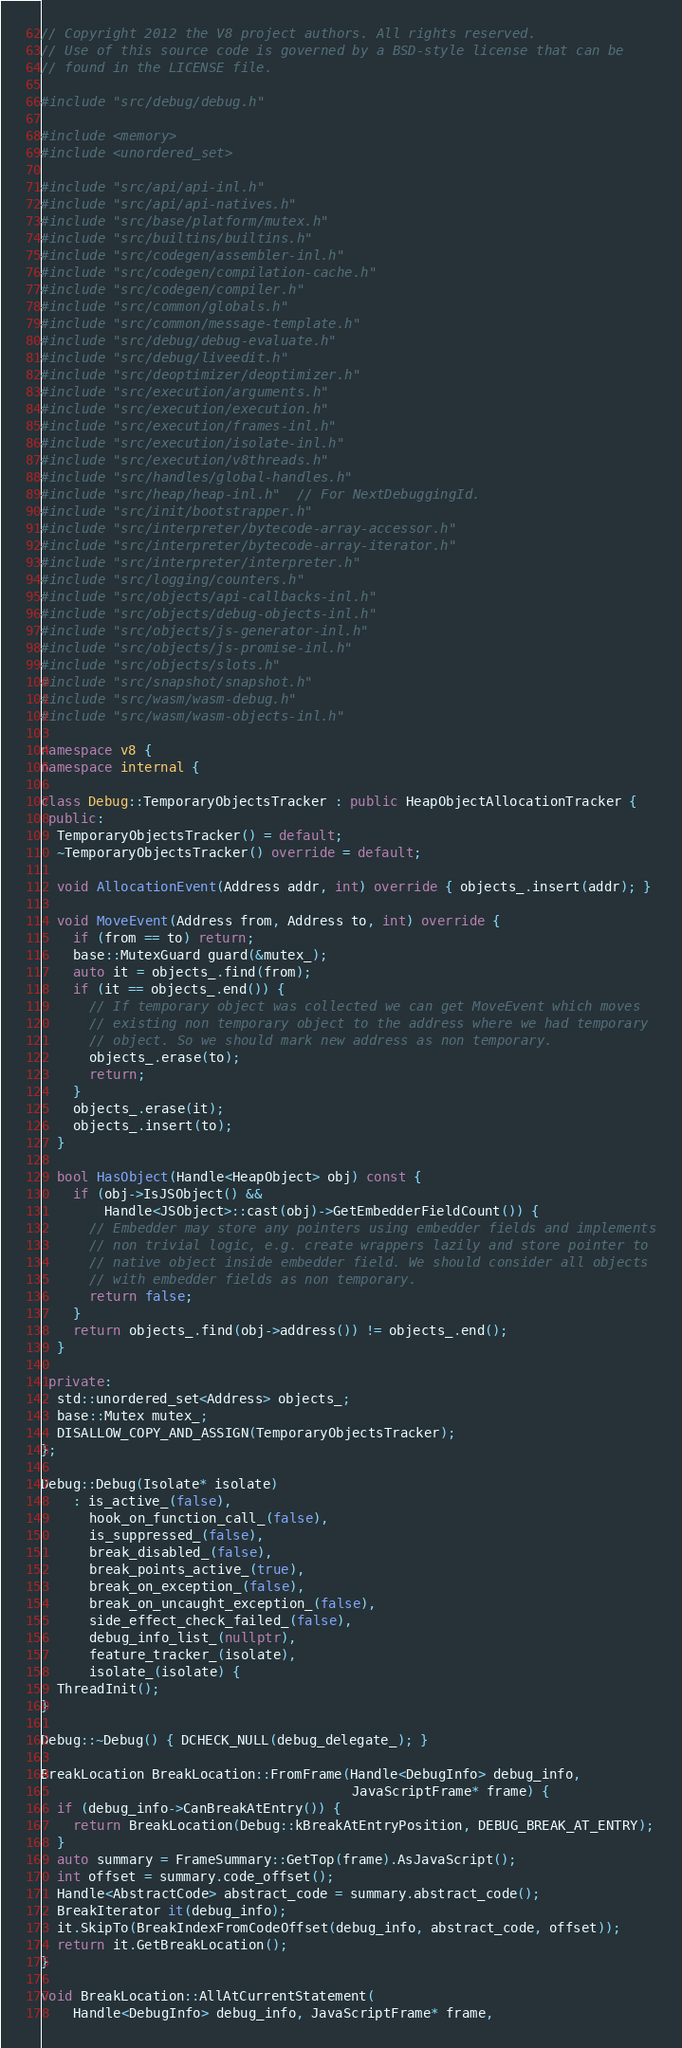Convert code to text. <code><loc_0><loc_0><loc_500><loc_500><_C++_>// Copyright 2012 the V8 project authors. All rights reserved.
// Use of this source code is governed by a BSD-style license that can be
// found in the LICENSE file.

#include "src/debug/debug.h"

#include <memory>
#include <unordered_set>

#include "src/api/api-inl.h"
#include "src/api/api-natives.h"
#include "src/base/platform/mutex.h"
#include "src/builtins/builtins.h"
#include "src/codegen/assembler-inl.h"
#include "src/codegen/compilation-cache.h"
#include "src/codegen/compiler.h"
#include "src/common/globals.h"
#include "src/common/message-template.h"
#include "src/debug/debug-evaluate.h"
#include "src/debug/liveedit.h"
#include "src/deoptimizer/deoptimizer.h"
#include "src/execution/arguments.h"
#include "src/execution/execution.h"
#include "src/execution/frames-inl.h"
#include "src/execution/isolate-inl.h"
#include "src/execution/v8threads.h"
#include "src/handles/global-handles.h"
#include "src/heap/heap-inl.h"  // For NextDebuggingId.
#include "src/init/bootstrapper.h"
#include "src/interpreter/bytecode-array-accessor.h"
#include "src/interpreter/bytecode-array-iterator.h"
#include "src/interpreter/interpreter.h"
#include "src/logging/counters.h"
#include "src/objects/api-callbacks-inl.h"
#include "src/objects/debug-objects-inl.h"
#include "src/objects/js-generator-inl.h"
#include "src/objects/js-promise-inl.h"
#include "src/objects/slots.h"
#include "src/snapshot/snapshot.h"
#include "src/wasm/wasm-debug.h"
#include "src/wasm/wasm-objects-inl.h"

namespace v8 {
namespace internal {

class Debug::TemporaryObjectsTracker : public HeapObjectAllocationTracker {
 public:
  TemporaryObjectsTracker() = default;
  ~TemporaryObjectsTracker() override = default;

  void AllocationEvent(Address addr, int) override { objects_.insert(addr); }

  void MoveEvent(Address from, Address to, int) override {
    if (from == to) return;
    base::MutexGuard guard(&mutex_);
    auto it = objects_.find(from);
    if (it == objects_.end()) {
      // If temporary object was collected we can get MoveEvent which moves
      // existing non temporary object to the address where we had temporary
      // object. So we should mark new address as non temporary.
      objects_.erase(to);
      return;
    }
    objects_.erase(it);
    objects_.insert(to);
  }

  bool HasObject(Handle<HeapObject> obj) const {
    if (obj->IsJSObject() &&
        Handle<JSObject>::cast(obj)->GetEmbedderFieldCount()) {
      // Embedder may store any pointers using embedder fields and implements
      // non trivial logic, e.g. create wrappers lazily and store pointer to
      // native object inside embedder field. We should consider all objects
      // with embedder fields as non temporary.
      return false;
    }
    return objects_.find(obj->address()) != objects_.end();
  }

 private:
  std::unordered_set<Address> objects_;
  base::Mutex mutex_;
  DISALLOW_COPY_AND_ASSIGN(TemporaryObjectsTracker);
};

Debug::Debug(Isolate* isolate)
    : is_active_(false),
      hook_on_function_call_(false),
      is_suppressed_(false),
      break_disabled_(false),
      break_points_active_(true),
      break_on_exception_(false),
      break_on_uncaught_exception_(false),
      side_effect_check_failed_(false),
      debug_info_list_(nullptr),
      feature_tracker_(isolate),
      isolate_(isolate) {
  ThreadInit();
}

Debug::~Debug() { DCHECK_NULL(debug_delegate_); }

BreakLocation BreakLocation::FromFrame(Handle<DebugInfo> debug_info,
                                       JavaScriptFrame* frame) {
  if (debug_info->CanBreakAtEntry()) {
    return BreakLocation(Debug::kBreakAtEntryPosition, DEBUG_BREAK_AT_ENTRY);
  }
  auto summary = FrameSummary::GetTop(frame).AsJavaScript();
  int offset = summary.code_offset();
  Handle<AbstractCode> abstract_code = summary.abstract_code();
  BreakIterator it(debug_info);
  it.SkipTo(BreakIndexFromCodeOffset(debug_info, abstract_code, offset));
  return it.GetBreakLocation();
}

void BreakLocation::AllAtCurrentStatement(
    Handle<DebugInfo> debug_info, JavaScriptFrame* frame,</code> 